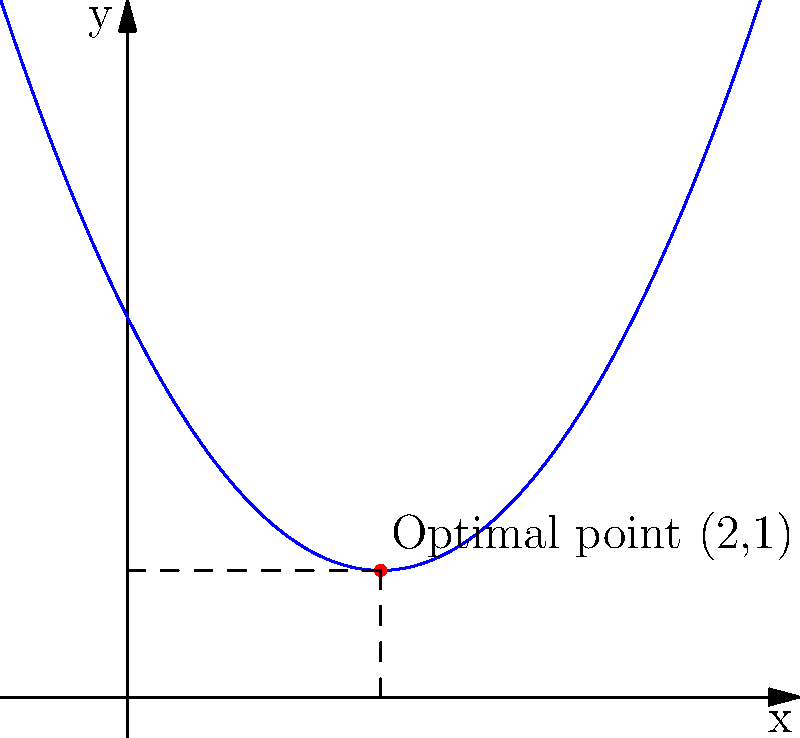In our sacred circle, we arrange ceremonial objects based on their spiritual significance. The placement follows a pattern described by the polynomial $f(x) = 0.5x^2 - 2x + 3$, where $x$ represents the distance from the center and $f(x)$ represents the object's spiritual energy. At what distance from the center should we place the most spiritually potent object to maximize its energy within the circle? To find the optimal placement, we need to determine the minimum point of the polynomial function, as this represents the highest spiritual energy.

1. The polynomial is in the form $f(x) = ax^2 + bx + c$, where $a = 0.5$, $b = -2$, and $c = 3$.

2. For a quadratic function, the x-coordinate of the vertex (minimum or maximum point) is given by the formula: $x = -\frac{b}{2a}$

3. Substituting our values:
   $x = -\frac{(-2)}{2(0.5)} = \frac{2}{1} = 2$

4. To find the y-coordinate, we substitute x = 2 into the original function:
   $f(2) = 0.5(2)^2 - 2(2) + 3$
   $= 0.5(4) - 4 + 3$
   $= 2 - 4 + 3 = 1$

5. Therefore, the vertex of the parabola is at the point (2, 1).

This means the most spiritually potent object should be placed at a distance of 2 units from the center of the circle to maximize its energy.
Answer: 2 units from the center 